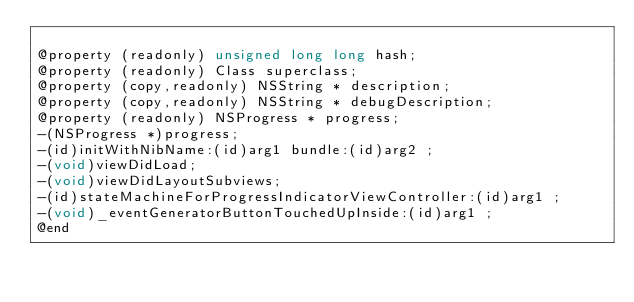<code> <loc_0><loc_0><loc_500><loc_500><_C_>
@property (readonly) unsigned long long hash; 
@property (readonly) Class superclass; 
@property (copy,readonly) NSString * description; 
@property (copy,readonly) NSString * debugDescription; 
@property (readonly) NSProgress * progress; 
-(NSProgress *)progress;
-(id)initWithNibName:(id)arg1 bundle:(id)arg2 ;
-(void)viewDidLoad;
-(void)viewDidLayoutSubviews;
-(id)stateMachineForProgressIndicatorViewController:(id)arg1 ;
-(void)_eventGeneratorButtonTouchedUpInside:(id)arg1 ;
@end

</code> 